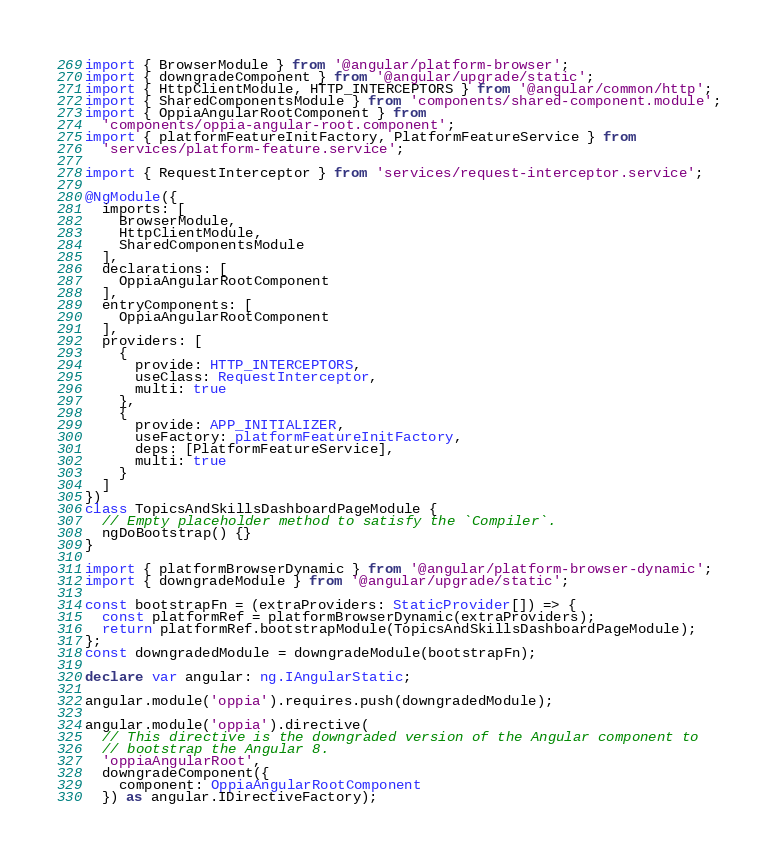Convert code to text. <code><loc_0><loc_0><loc_500><loc_500><_TypeScript_>import { BrowserModule } from '@angular/platform-browser';
import { downgradeComponent } from '@angular/upgrade/static';
import { HttpClientModule, HTTP_INTERCEPTORS } from '@angular/common/http';
import { SharedComponentsModule } from 'components/shared-component.module';
import { OppiaAngularRootComponent } from
  'components/oppia-angular-root.component';
import { platformFeatureInitFactory, PlatformFeatureService } from
  'services/platform-feature.service';

import { RequestInterceptor } from 'services/request-interceptor.service';

@NgModule({
  imports: [
    BrowserModule,
    HttpClientModule,
    SharedComponentsModule
  ],
  declarations: [
    OppiaAngularRootComponent
  ],
  entryComponents: [
    OppiaAngularRootComponent
  ],
  providers: [
    {
      provide: HTTP_INTERCEPTORS,
      useClass: RequestInterceptor,
      multi: true
    },
    {
      provide: APP_INITIALIZER,
      useFactory: platformFeatureInitFactory,
      deps: [PlatformFeatureService],
      multi: true
    }
  ]
})
class TopicsAndSkillsDashboardPageModule {
  // Empty placeholder method to satisfy the `Compiler`.
  ngDoBootstrap() {}
}

import { platformBrowserDynamic } from '@angular/platform-browser-dynamic';
import { downgradeModule } from '@angular/upgrade/static';

const bootstrapFn = (extraProviders: StaticProvider[]) => {
  const platformRef = platformBrowserDynamic(extraProviders);
  return platformRef.bootstrapModule(TopicsAndSkillsDashboardPageModule);
};
const downgradedModule = downgradeModule(bootstrapFn);

declare var angular: ng.IAngularStatic;

angular.module('oppia').requires.push(downgradedModule);

angular.module('oppia').directive(
  // This directive is the downgraded version of the Angular component to
  // bootstrap the Angular 8.
  'oppiaAngularRoot',
  downgradeComponent({
    component: OppiaAngularRootComponent
  }) as angular.IDirectiveFactory);
</code> 